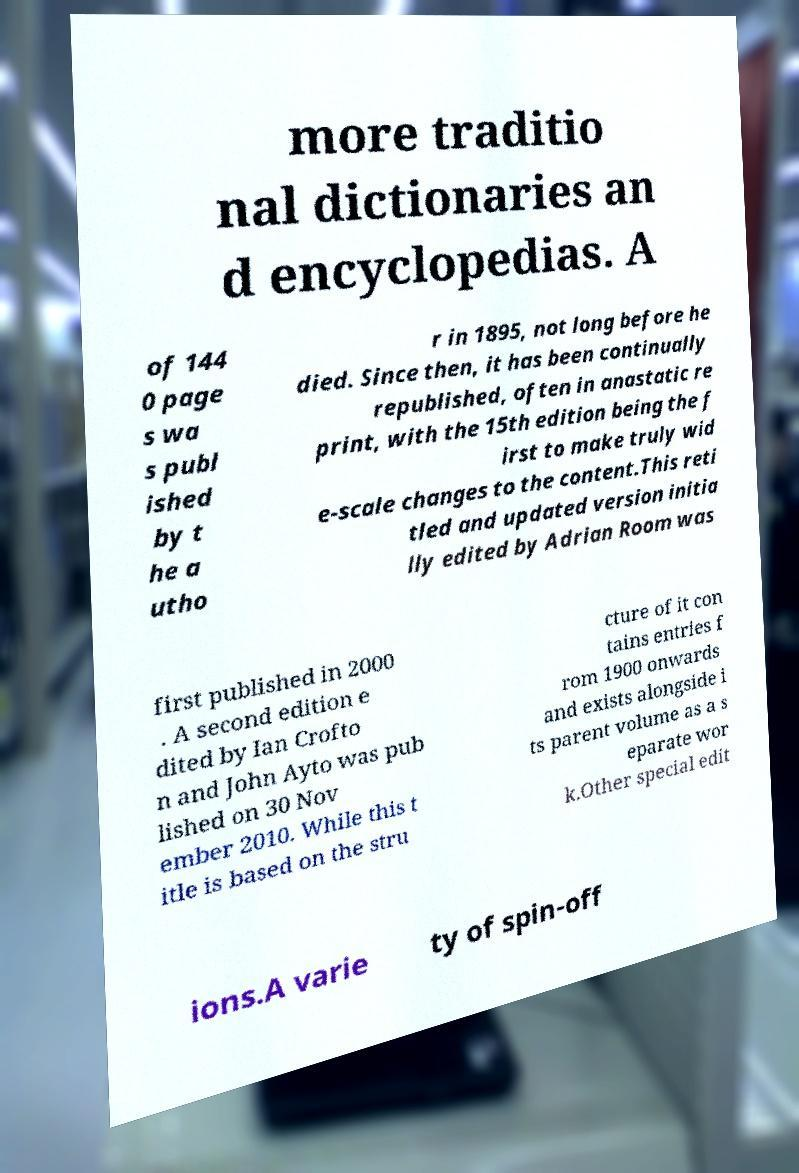For documentation purposes, I need the text within this image transcribed. Could you provide that? more traditio nal dictionaries an d encyclopedias. A of 144 0 page s wa s publ ished by t he a utho r in 1895, not long before he died. Since then, it has been continually republished, often in anastatic re print, with the 15th edition being the f irst to make truly wid e-scale changes to the content.This reti tled and updated version initia lly edited by Adrian Room was first published in 2000 . A second edition e dited by Ian Crofto n and John Ayto was pub lished on 30 Nov ember 2010. While this t itle is based on the stru cture of it con tains entries f rom 1900 onwards and exists alongside i ts parent volume as a s eparate wor k.Other special edit ions.A varie ty of spin-off 